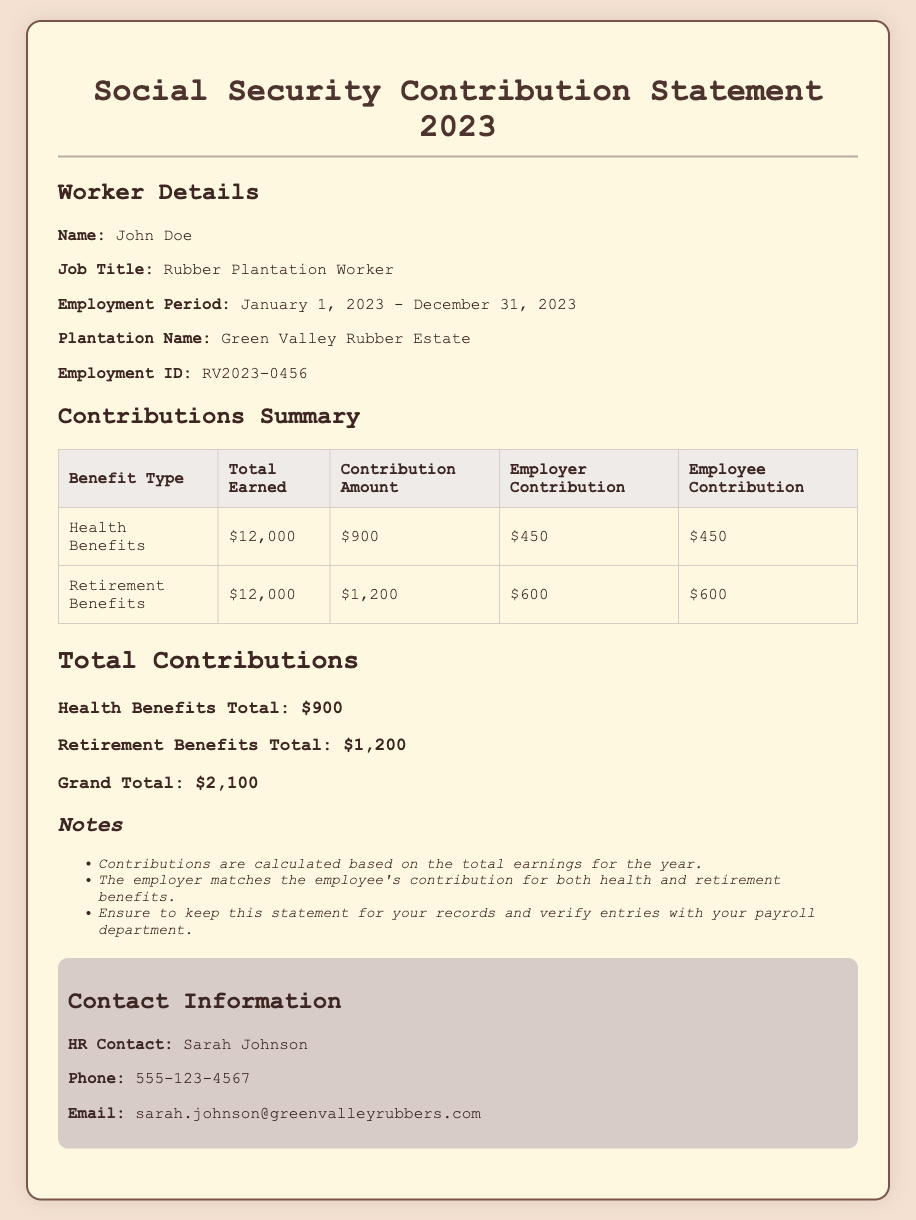What is the worker's name? The worker's name is listed in the document under 'Worker Details.'
Answer: John Doe What is the job title of the worker? The job title can be found in the 'Worker Details' section.
Answer: Rubber Plantation Worker What was the total earned for health benefits? The total earned for health benefits is specified in the contributions summary table.
Answer: $12,000 How much was the employee contribution for retirement benefits? The employee contribution for retirement benefits is outlined in the contributions summary table.
Answer: $600 What is the grand total of all contributions? The grand total of contributions can be found in the 'Total Contributions' section.
Answer: $2,100 Who can be contacted for HR inquiries? The HR contact name is provided in the 'Contact Information' section.
Answer: Sarah Johnson What is the duration of the employment period? The employment period is stated in the 'Worker Details' section of the document.
Answer: January 1, 2023 - December 31, 2023 Does the employer match the employee's contributions? There’s a note stating that the employer matches the employee's contributions.
Answer: Yes How much was paid for health benefits in total? The total for health benefits is specified under 'Total Contributions.'
Answer: $900 